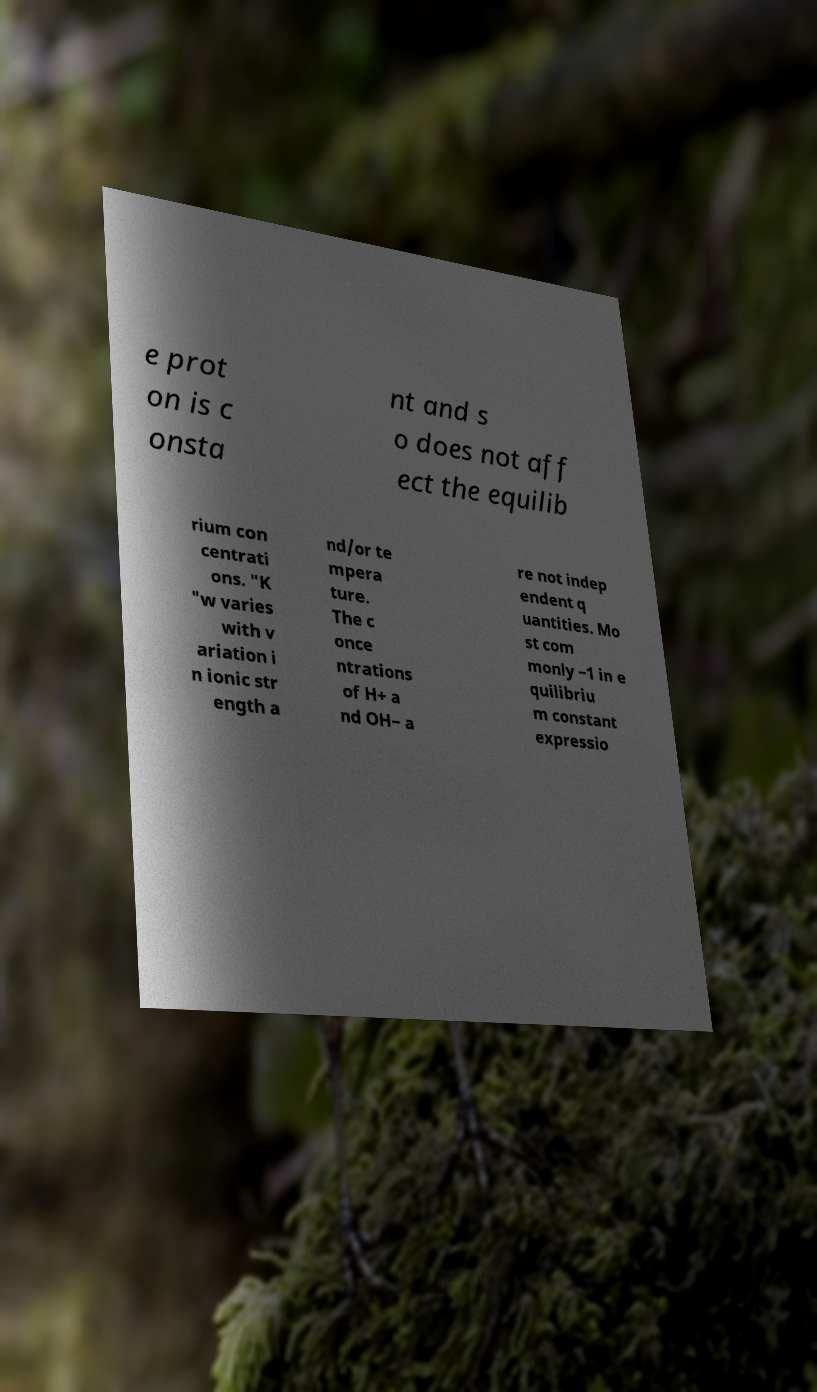Could you extract and type out the text from this image? e prot on is c onsta nt and s o does not aff ect the equilib rium con centrati ons. "K "w varies with v ariation i n ionic str ength a nd/or te mpera ture. The c once ntrations of H+ a nd OH− a re not indep endent q uantities. Mo st com monly −1 in e quilibriu m constant expressio 